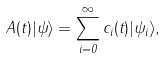<formula> <loc_0><loc_0><loc_500><loc_500>A ( t ) | \psi \rangle = \sum _ { i = 0 } ^ { \infty } c _ { i } ( t ) | \psi _ { i } \rangle ,</formula> 